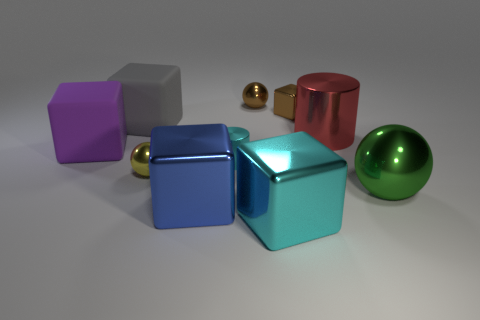What might be the material of these objects, and would they weigh the same? The objects appear to be made of a highly reflective metal, which gives them a shiny surface. Despite the visual similarity in material, they likely vary in weight. The spheres, for instance, despite differing in size from the cubes, may weigh more or less due to factors like thickness and density of the material used. 